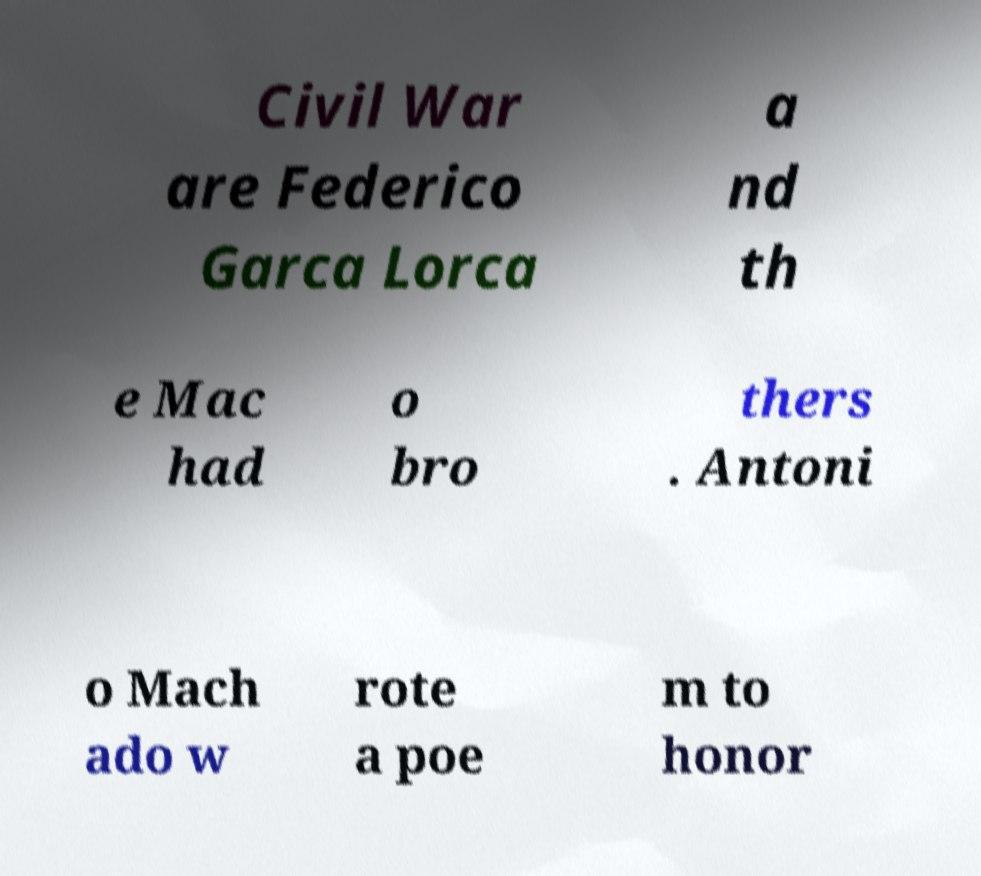Could you extract and type out the text from this image? Civil War are Federico Garca Lorca a nd th e Mac had o bro thers . Antoni o Mach ado w rote a poe m to honor 